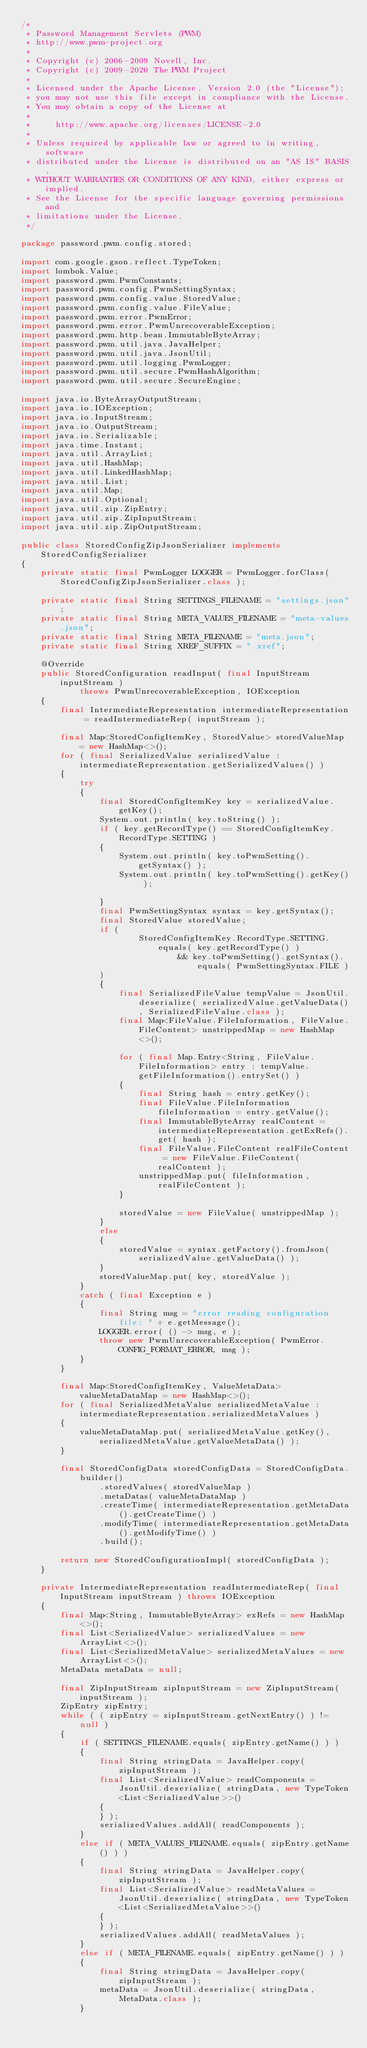Convert code to text. <code><loc_0><loc_0><loc_500><loc_500><_Java_>/*
 * Password Management Servlets (PWM)
 * http://www.pwm-project.org
 *
 * Copyright (c) 2006-2009 Novell, Inc.
 * Copyright (c) 2009-2020 The PWM Project
 *
 * Licensed under the Apache License, Version 2.0 (the "License");
 * you may not use this file except in compliance with the License.
 * You may obtain a copy of the License at
 *
 *     http://www.apache.org/licenses/LICENSE-2.0
 *
 * Unless required by applicable law or agreed to in writing, software
 * distributed under the License is distributed on an "AS IS" BASIS,
 * WITHOUT WARRANTIES OR CONDITIONS OF ANY KIND, either express or implied.
 * See the License for the specific language governing permissions and
 * limitations under the License.
 */

package password.pwm.config.stored;

import com.google.gson.reflect.TypeToken;
import lombok.Value;
import password.pwm.PwmConstants;
import password.pwm.config.PwmSettingSyntax;
import password.pwm.config.value.StoredValue;
import password.pwm.config.value.FileValue;
import password.pwm.error.PwmError;
import password.pwm.error.PwmUnrecoverableException;
import password.pwm.http.bean.ImmutableByteArray;
import password.pwm.util.java.JavaHelper;
import password.pwm.util.java.JsonUtil;
import password.pwm.util.logging.PwmLogger;
import password.pwm.util.secure.PwmHashAlgorithm;
import password.pwm.util.secure.SecureEngine;

import java.io.ByteArrayOutputStream;
import java.io.IOException;
import java.io.InputStream;
import java.io.OutputStream;
import java.io.Serializable;
import java.time.Instant;
import java.util.ArrayList;
import java.util.HashMap;
import java.util.LinkedHashMap;
import java.util.List;
import java.util.Map;
import java.util.Optional;
import java.util.zip.ZipEntry;
import java.util.zip.ZipInputStream;
import java.util.zip.ZipOutputStream;

public class StoredConfigZipJsonSerializer implements StoredConfigSerializer
{
    private static final PwmLogger LOGGER = PwmLogger.forClass( StoredConfigZipJsonSerializer.class );

    private static final String SETTINGS_FILENAME = "settings.json";
    private static final String META_VALUES_FILENAME = "meta-values.json";
    private static final String META_FILENAME = "meta.json";
    private static final String XREF_SUFFIX = ".xref";

    @Override
    public StoredConfiguration readInput( final InputStream inputStream )
            throws PwmUnrecoverableException, IOException
    {
        final IntermediateRepresentation intermediateRepresentation = readIntermediateRep( inputStream );

        final Map<StoredConfigItemKey, StoredValue> storedValueMap = new HashMap<>();
        for ( final SerializedValue serializedValue : intermediateRepresentation.getSerializedValues() )
        {
            try
            {
                final StoredConfigItemKey key = serializedValue.getKey();
                System.out.println( key.toString() );
                if ( key.getRecordType() == StoredConfigItemKey.RecordType.SETTING )
                {
                    System.out.println( key.toPwmSetting().getSyntax() );
                    System.out.println( key.toPwmSetting().getKey() );

                }
                final PwmSettingSyntax syntax = key.getSyntax();
                final StoredValue storedValue;
                if (
                        StoredConfigItemKey.RecordType.SETTING.equals( key.getRecordType() )
                                && key.toPwmSetting().getSyntax().equals( PwmSettingSyntax.FILE )
                )
                {
                    final SerializedFileValue tempValue = JsonUtil.deserialize( serializedValue.getValueData(), SerializedFileValue.class );
                    final Map<FileValue.FileInformation, FileValue.FileContent> unstrippedMap = new HashMap<>();

                    for ( final Map.Entry<String, FileValue.FileInformation> entry : tempValue.getFileInformation().entrySet() )
                    {
                        final String hash = entry.getKey();
                        final FileValue.FileInformation fileInformation = entry.getValue();
                        final ImmutableByteArray realContent = intermediateRepresentation.getExRefs().get( hash );
                        final FileValue.FileContent realFileContent = new FileValue.FileContent( realContent );
                        unstrippedMap.put( fileInformation, realFileContent );
                    }

                    storedValue = new FileValue( unstrippedMap );
                }
                else
                {
                    storedValue = syntax.getFactory().fromJson( serializedValue.getValueData() );
                }
                storedValueMap.put( key, storedValue );
            }
            catch ( final Exception e )
            {
                final String msg = "error reading configuration file: " + e.getMessage();
                LOGGER.error( () -> msg, e );
                throw new PwmUnrecoverableException( PwmError.CONFIG_FORMAT_ERROR, msg );
            }
        }

        final Map<StoredConfigItemKey, ValueMetaData> valueMetaDataMap = new HashMap<>();
        for ( final SerializedMetaValue serializedMetaValue : intermediateRepresentation.serializedMetaValues )
        {
            valueMetaDataMap.put( serializedMetaValue.getKey(), serializedMetaValue.getValueMetaData() );
        }

        final StoredConfigData storedConfigData = StoredConfigData.builder()
                .storedValues( storedValueMap )
                .metaDatas( valueMetaDataMap )
                .createTime( intermediateRepresentation.getMetaData().getCreateTime() )
                .modifyTime( intermediateRepresentation.getMetaData().getModifyTime() )
                .build();

        return new StoredConfigurationImpl( storedConfigData );
    }

    private IntermediateRepresentation readIntermediateRep( final InputStream inputStream ) throws IOException
    {
        final Map<String, ImmutableByteArray> exRefs = new HashMap<>();
        final List<SerializedValue> serializedValues = new ArrayList<>();
        final List<SerializedMetaValue> serializedMetaValues = new ArrayList<>();
        MetaData metaData = null;

        final ZipInputStream zipInputStream = new ZipInputStream( inputStream );
        ZipEntry zipEntry;
        while ( ( zipEntry = zipInputStream.getNextEntry() ) != null )
        {
            if ( SETTINGS_FILENAME.equals( zipEntry.getName() ) )
            {
                final String stringData = JavaHelper.copy( zipInputStream );
                final List<SerializedValue> readComponents = JsonUtil.deserialize( stringData, new TypeToken<List<SerializedValue>>()
                {
                } );
                serializedValues.addAll( readComponents );
            }
            else if ( META_VALUES_FILENAME.equals( zipEntry.getName() ) )
            {
                final String stringData = JavaHelper.copy( zipInputStream );
                final List<SerializedValue> readMetaValues = JsonUtil.deserialize( stringData, new TypeToken<List<SerializedMetaValue>>()
                {
                } );
                serializedValues.addAll( readMetaValues );
            }
            else if ( META_FILENAME.equals( zipEntry.getName() ) )
            {
                final String stringData = JavaHelper.copy( zipInputStream );
                metaData = JsonUtil.deserialize( stringData, MetaData.class );
            }</code> 